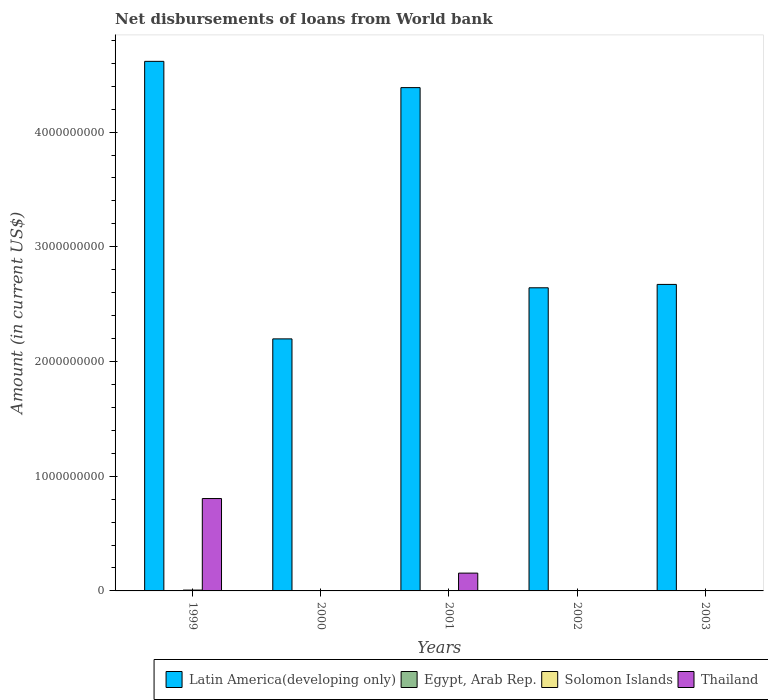Are the number of bars on each tick of the X-axis equal?
Provide a succinct answer. No. How many bars are there on the 5th tick from the left?
Give a very brief answer. 1. Across all years, what is the maximum amount of loan disbursed from World Bank in Solomon Islands?
Make the answer very short. 7.23e+06. Across all years, what is the minimum amount of loan disbursed from World Bank in Thailand?
Your answer should be compact. 0. In which year was the amount of loan disbursed from World Bank in Thailand maximum?
Provide a short and direct response. 1999. What is the difference between the amount of loan disbursed from World Bank in Latin America(developing only) in 2000 and that in 2003?
Ensure brevity in your answer.  -4.75e+08. What is the average amount of loan disbursed from World Bank in Latin America(developing only) per year?
Give a very brief answer. 3.30e+09. In the year 2001, what is the difference between the amount of loan disbursed from World Bank in Thailand and amount of loan disbursed from World Bank in Latin America(developing only)?
Keep it short and to the point. -4.23e+09. What is the ratio of the amount of loan disbursed from World Bank in Latin America(developing only) in 1999 to that in 2002?
Offer a terse response. 1.75. Is the amount of loan disbursed from World Bank in Solomon Islands in 1999 less than that in 2000?
Make the answer very short. No. What is the difference between the highest and the second highest amount of loan disbursed from World Bank in Latin America(developing only)?
Your answer should be compact. 2.29e+08. What is the difference between the highest and the lowest amount of loan disbursed from World Bank in Thailand?
Make the answer very short. 8.05e+08. Is it the case that in every year, the sum of the amount of loan disbursed from World Bank in Thailand and amount of loan disbursed from World Bank in Solomon Islands is greater than the sum of amount of loan disbursed from World Bank in Latin America(developing only) and amount of loan disbursed from World Bank in Egypt, Arab Rep.?
Offer a very short reply. No. Is it the case that in every year, the sum of the amount of loan disbursed from World Bank in Thailand and amount of loan disbursed from World Bank in Latin America(developing only) is greater than the amount of loan disbursed from World Bank in Egypt, Arab Rep.?
Offer a very short reply. Yes. How many bars are there?
Keep it short and to the point. 10. Are all the bars in the graph horizontal?
Provide a short and direct response. No. How many years are there in the graph?
Keep it short and to the point. 5. What is the difference between two consecutive major ticks on the Y-axis?
Provide a succinct answer. 1.00e+09. Does the graph contain any zero values?
Your answer should be compact. Yes. How many legend labels are there?
Offer a very short reply. 4. How are the legend labels stacked?
Provide a succinct answer. Horizontal. What is the title of the graph?
Ensure brevity in your answer.  Net disbursements of loans from World bank. What is the label or title of the X-axis?
Your answer should be compact. Years. What is the label or title of the Y-axis?
Your response must be concise. Amount (in current US$). What is the Amount (in current US$) of Latin America(developing only) in 1999?
Keep it short and to the point. 4.62e+09. What is the Amount (in current US$) in Solomon Islands in 1999?
Your response must be concise. 7.23e+06. What is the Amount (in current US$) of Thailand in 1999?
Ensure brevity in your answer.  8.05e+08. What is the Amount (in current US$) in Latin America(developing only) in 2000?
Give a very brief answer. 2.20e+09. What is the Amount (in current US$) in Egypt, Arab Rep. in 2000?
Keep it short and to the point. 0. What is the Amount (in current US$) of Solomon Islands in 2000?
Your response must be concise. 2.63e+05. What is the Amount (in current US$) in Thailand in 2000?
Offer a very short reply. 0. What is the Amount (in current US$) in Latin America(developing only) in 2001?
Keep it short and to the point. 4.39e+09. What is the Amount (in current US$) in Egypt, Arab Rep. in 2001?
Your response must be concise. 0. What is the Amount (in current US$) of Solomon Islands in 2001?
Your response must be concise. 9.77e+05. What is the Amount (in current US$) of Thailand in 2001?
Offer a very short reply. 1.55e+08. What is the Amount (in current US$) of Latin America(developing only) in 2002?
Your response must be concise. 2.64e+09. What is the Amount (in current US$) of Egypt, Arab Rep. in 2002?
Ensure brevity in your answer.  0. What is the Amount (in current US$) of Solomon Islands in 2002?
Offer a very short reply. 0. What is the Amount (in current US$) in Thailand in 2002?
Offer a terse response. 0. What is the Amount (in current US$) of Latin America(developing only) in 2003?
Give a very brief answer. 2.67e+09. What is the Amount (in current US$) of Egypt, Arab Rep. in 2003?
Your answer should be compact. 0. Across all years, what is the maximum Amount (in current US$) in Latin America(developing only)?
Keep it short and to the point. 4.62e+09. Across all years, what is the maximum Amount (in current US$) of Solomon Islands?
Offer a terse response. 7.23e+06. Across all years, what is the maximum Amount (in current US$) of Thailand?
Offer a terse response. 8.05e+08. Across all years, what is the minimum Amount (in current US$) in Latin America(developing only)?
Provide a succinct answer. 2.20e+09. Across all years, what is the minimum Amount (in current US$) of Solomon Islands?
Your answer should be very brief. 0. Across all years, what is the minimum Amount (in current US$) of Thailand?
Ensure brevity in your answer.  0. What is the total Amount (in current US$) in Latin America(developing only) in the graph?
Your answer should be compact. 1.65e+1. What is the total Amount (in current US$) of Solomon Islands in the graph?
Keep it short and to the point. 8.47e+06. What is the total Amount (in current US$) of Thailand in the graph?
Your answer should be compact. 9.61e+08. What is the difference between the Amount (in current US$) in Latin America(developing only) in 1999 and that in 2000?
Give a very brief answer. 2.42e+09. What is the difference between the Amount (in current US$) in Solomon Islands in 1999 and that in 2000?
Make the answer very short. 6.97e+06. What is the difference between the Amount (in current US$) in Latin America(developing only) in 1999 and that in 2001?
Your response must be concise. 2.29e+08. What is the difference between the Amount (in current US$) of Solomon Islands in 1999 and that in 2001?
Provide a succinct answer. 6.25e+06. What is the difference between the Amount (in current US$) of Thailand in 1999 and that in 2001?
Keep it short and to the point. 6.50e+08. What is the difference between the Amount (in current US$) in Latin America(developing only) in 1999 and that in 2002?
Your response must be concise. 1.97e+09. What is the difference between the Amount (in current US$) in Latin America(developing only) in 1999 and that in 2003?
Offer a very short reply. 1.94e+09. What is the difference between the Amount (in current US$) of Latin America(developing only) in 2000 and that in 2001?
Offer a terse response. -2.19e+09. What is the difference between the Amount (in current US$) in Solomon Islands in 2000 and that in 2001?
Your answer should be compact. -7.14e+05. What is the difference between the Amount (in current US$) in Latin America(developing only) in 2000 and that in 2002?
Offer a terse response. -4.45e+08. What is the difference between the Amount (in current US$) of Latin America(developing only) in 2000 and that in 2003?
Provide a short and direct response. -4.75e+08. What is the difference between the Amount (in current US$) of Latin America(developing only) in 2001 and that in 2002?
Your answer should be compact. 1.74e+09. What is the difference between the Amount (in current US$) in Latin America(developing only) in 2001 and that in 2003?
Keep it short and to the point. 1.72e+09. What is the difference between the Amount (in current US$) of Latin America(developing only) in 2002 and that in 2003?
Your response must be concise. -2.93e+07. What is the difference between the Amount (in current US$) in Latin America(developing only) in 1999 and the Amount (in current US$) in Solomon Islands in 2000?
Give a very brief answer. 4.62e+09. What is the difference between the Amount (in current US$) in Latin America(developing only) in 1999 and the Amount (in current US$) in Solomon Islands in 2001?
Your answer should be very brief. 4.62e+09. What is the difference between the Amount (in current US$) of Latin America(developing only) in 1999 and the Amount (in current US$) of Thailand in 2001?
Provide a succinct answer. 4.46e+09. What is the difference between the Amount (in current US$) of Solomon Islands in 1999 and the Amount (in current US$) of Thailand in 2001?
Your answer should be very brief. -1.48e+08. What is the difference between the Amount (in current US$) in Latin America(developing only) in 2000 and the Amount (in current US$) in Solomon Islands in 2001?
Give a very brief answer. 2.20e+09. What is the difference between the Amount (in current US$) in Latin America(developing only) in 2000 and the Amount (in current US$) in Thailand in 2001?
Make the answer very short. 2.04e+09. What is the difference between the Amount (in current US$) of Solomon Islands in 2000 and the Amount (in current US$) of Thailand in 2001?
Offer a very short reply. -1.55e+08. What is the average Amount (in current US$) of Latin America(developing only) per year?
Your answer should be compact. 3.30e+09. What is the average Amount (in current US$) in Egypt, Arab Rep. per year?
Ensure brevity in your answer.  0. What is the average Amount (in current US$) in Solomon Islands per year?
Ensure brevity in your answer.  1.69e+06. What is the average Amount (in current US$) of Thailand per year?
Provide a succinct answer. 1.92e+08. In the year 1999, what is the difference between the Amount (in current US$) in Latin America(developing only) and Amount (in current US$) in Solomon Islands?
Keep it short and to the point. 4.61e+09. In the year 1999, what is the difference between the Amount (in current US$) of Latin America(developing only) and Amount (in current US$) of Thailand?
Keep it short and to the point. 3.81e+09. In the year 1999, what is the difference between the Amount (in current US$) in Solomon Islands and Amount (in current US$) in Thailand?
Make the answer very short. -7.98e+08. In the year 2000, what is the difference between the Amount (in current US$) in Latin America(developing only) and Amount (in current US$) in Solomon Islands?
Offer a very short reply. 2.20e+09. In the year 2001, what is the difference between the Amount (in current US$) in Latin America(developing only) and Amount (in current US$) in Solomon Islands?
Make the answer very short. 4.39e+09. In the year 2001, what is the difference between the Amount (in current US$) of Latin America(developing only) and Amount (in current US$) of Thailand?
Keep it short and to the point. 4.23e+09. In the year 2001, what is the difference between the Amount (in current US$) in Solomon Islands and Amount (in current US$) in Thailand?
Give a very brief answer. -1.54e+08. What is the ratio of the Amount (in current US$) in Latin America(developing only) in 1999 to that in 2000?
Offer a terse response. 2.1. What is the ratio of the Amount (in current US$) of Solomon Islands in 1999 to that in 2000?
Keep it short and to the point. 27.49. What is the ratio of the Amount (in current US$) of Latin America(developing only) in 1999 to that in 2001?
Give a very brief answer. 1.05. What is the ratio of the Amount (in current US$) of Solomon Islands in 1999 to that in 2001?
Provide a succinct answer. 7.4. What is the ratio of the Amount (in current US$) in Thailand in 1999 to that in 2001?
Ensure brevity in your answer.  5.19. What is the ratio of the Amount (in current US$) in Latin America(developing only) in 1999 to that in 2002?
Keep it short and to the point. 1.75. What is the ratio of the Amount (in current US$) of Latin America(developing only) in 1999 to that in 2003?
Your response must be concise. 1.73. What is the ratio of the Amount (in current US$) in Latin America(developing only) in 2000 to that in 2001?
Your answer should be very brief. 0.5. What is the ratio of the Amount (in current US$) in Solomon Islands in 2000 to that in 2001?
Make the answer very short. 0.27. What is the ratio of the Amount (in current US$) in Latin America(developing only) in 2000 to that in 2002?
Your answer should be compact. 0.83. What is the ratio of the Amount (in current US$) of Latin America(developing only) in 2000 to that in 2003?
Keep it short and to the point. 0.82. What is the ratio of the Amount (in current US$) in Latin America(developing only) in 2001 to that in 2002?
Your answer should be very brief. 1.66. What is the ratio of the Amount (in current US$) in Latin America(developing only) in 2001 to that in 2003?
Provide a succinct answer. 1.64. What is the ratio of the Amount (in current US$) of Latin America(developing only) in 2002 to that in 2003?
Give a very brief answer. 0.99. What is the difference between the highest and the second highest Amount (in current US$) of Latin America(developing only)?
Ensure brevity in your answer.  2.29e+08. What is the difference between the highest and the second highest Amount (in current US$) of Solomon Islands?
Provide a short and direct response. 6.25e+06. What is the difference between the highest and the lowest Amount (in current US$) of Latin America(developing only)?
Provide a succinct answer. 2.42e+09. What is the difference between the highest and the lowest Amount (in current US$) of Solomon Islands?
Your answer should be compact. 7.23e+06. What is the difference between the highest and the lowest Amount (in current US$) of Thailand?
Make the answer very short. 8.05e+08. 